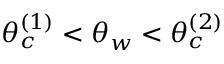<formula> <loc_0><loc_0><loc_500><loc_500>\theta _ { c } ^ { ( 1 ) } < \theta _ { w } < \theta _ { c } ^ { ( 2 ) }</formula> 